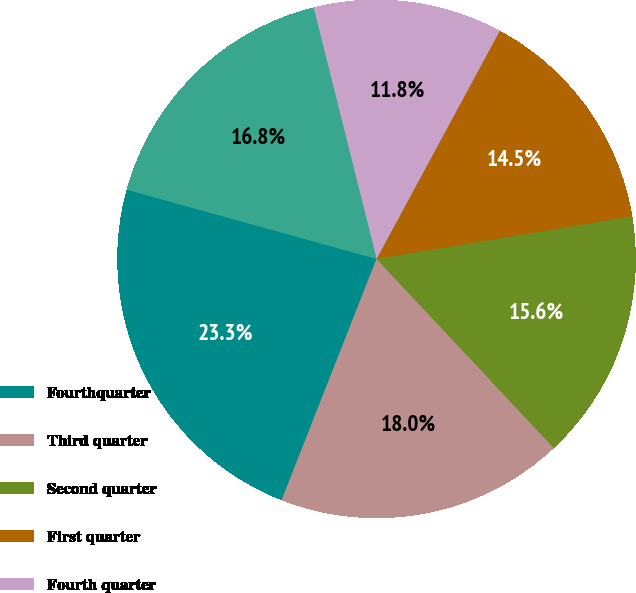Convert chart. <chart><loc_0><loc_0><loc_500><loc_500><pie_chart><fcel>Fourthquarter<fcel>Third quarter<fcel>Second quarter<fcel>First quarter<fcel>Fourth quarter<fcel>First Quarter<nl><fcel>23.34%<fcel>17.95%<fcel>15.64%<fcel>14.49%<fcel>11.79%<fcel>16.79%<nl></chart> 